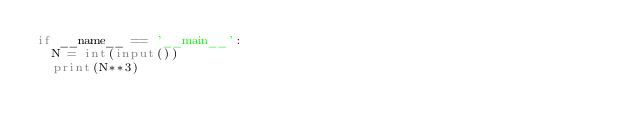Convert code to text. <code><loc_0><loc_0><loc_500><loc_500><_Python_>if __name__ == '__main__':
  N = int(input())
  print(N**3)</code> 